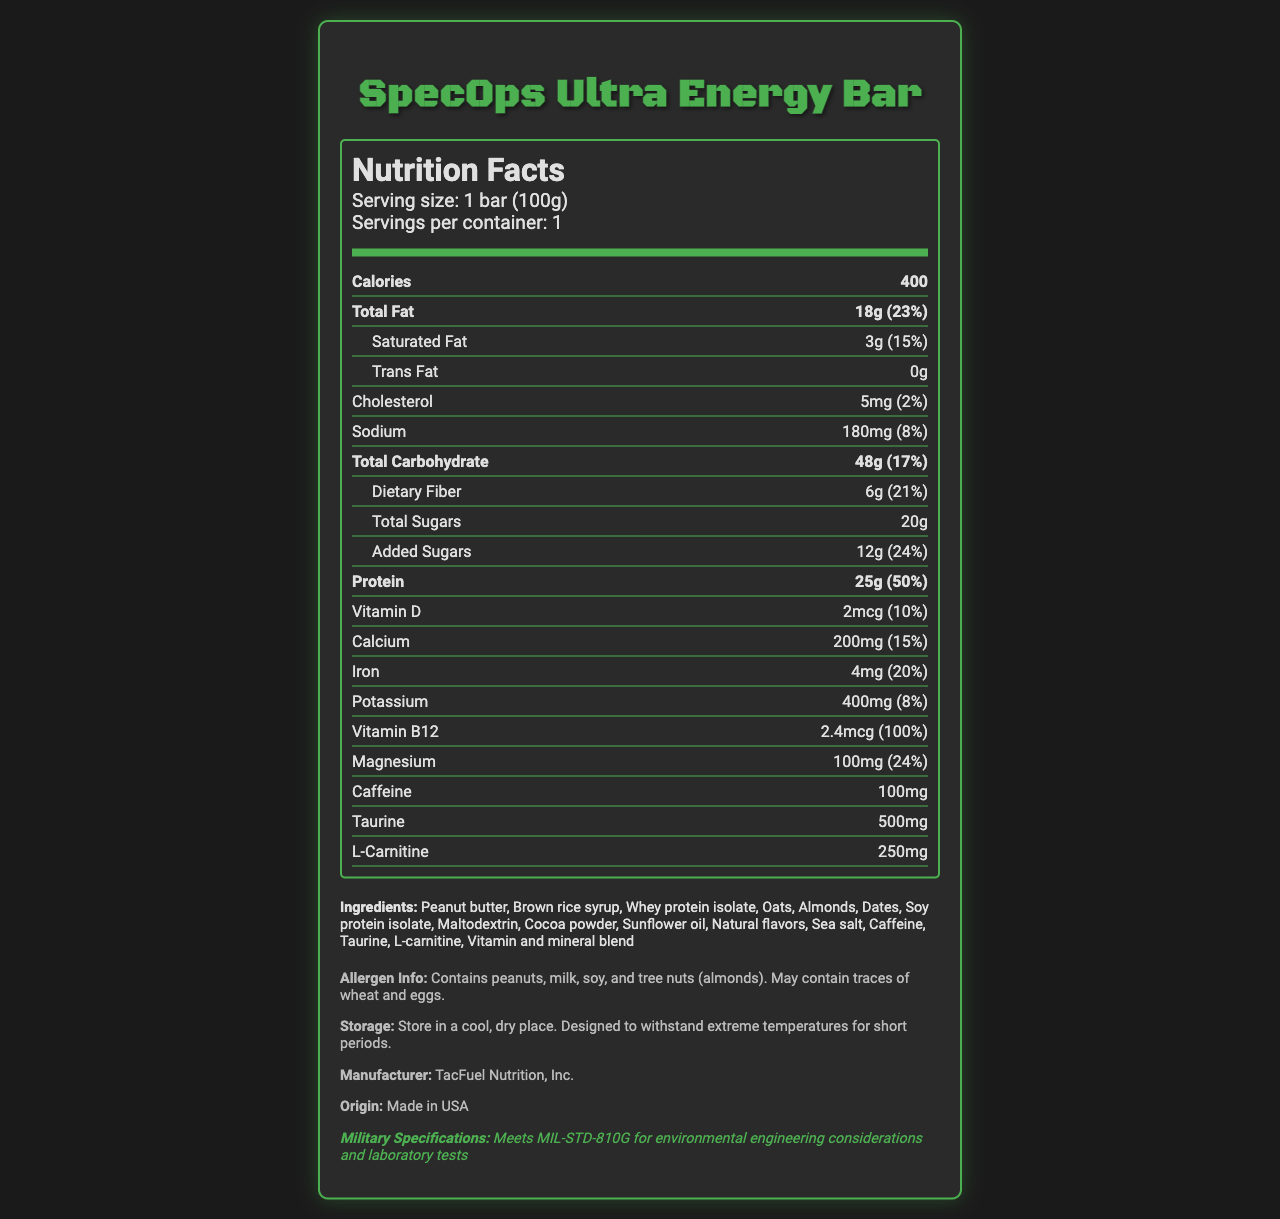What is the serving size for SpecOps Ultra Energy Bar? The serving size is clearly stated as "1 bar (100g)" in the serving information section.
Answer: 1 bar (100g) How many grams of total fat does one bar contain? The nutrition label lists "Total Fat" as 18g.
Answer: 18g What percentage of the daily value of protein does one bar provide? The nutrition facts state that one bar provides 50% of the daily value of protein.
Answer: 50% What is the amount of caffeine present in each bar? The nutrition label mentions that each bar contains 100mg of caffeine.
Answer: 100mg How much fiber is in one serving of the bar? The document specifies that one serving contains 6g of dietary fiber.
Answer: 6g How much calcium does one bar provide? The nutrition facts indicate that one bar includes 200mg of calcium.
Answer: 200mg What are the main allergens in this product? The allergen information section lists these allergens explicitly.
Answer: Peanuts, milk, soy, and tree nuts (almonds) What is the total carbohydrate content per bar? The document states that one bar has 48g of total carbohydrates.
Answer: 48g What percentage of the daily value of added sugars does this bar contain? The document notes that added sugars constitute 12g, representing 24% of the daily value.
Answer: 24% True or False: The SpecOps Ultra Energy Bar contains trans fats. The nutrition label specifies 0g of trans fats.
Answer: False What is the main purpose of this document? The document is a nutrition label designed to offer insight into the nutritional content and key ingredients of the energy bar.
Answer: To provide detailed nutritional information about the SpecOps Ultra Energy Bar What is the role of TacFuel Nutrition, Inc. as mentioned in the document? The additional info section identifies TacFuel Nutrition, Inc. as the manufacturer of the product.
Answer: Manufacturer Does this product comply with any military specifications? The document states that it meets MIL-STD-810G for environmental engineering considerations and laboratory tests.
Answer: Yes How should the SpecOps Ultra Energy Bar be stored? The storage instructions clearly indicate this method of storage.
Answer: Store in a cool, dry place. Designed to withstand extreme temperatures for short periods. How much saturated fat does one bar contain and what % daily value does it provide? The document lists saturated fat as 3g, providing 15% of the daily value.
Answer: 3g, 15% What are the special nutrient additives included in the bar? These amounts for caffeine, taurine, and L-carnitine are detailed in the nutrition section.
Answer: 100mg caffeine, 500mg taurine, 250mg L-carnitine Describe the visual style and primary content of the document. The document's design elements and comprehensive details aim to be informative and engaging, emphasizing its suitability for special forces operatives.
Answer: The document features a military-themed, visually striking nutrition facts label for the SpecOps Ultra Energy Bar, with detailed nutritional information, ingredient list, allergen info, and storage instructions. What is the exact amount of Vitamin C present in one bar? The document does not mention the amount of Vitamin C, if any, in the SpecOps Ultra Energy Bar.
Answer: Not enough information 